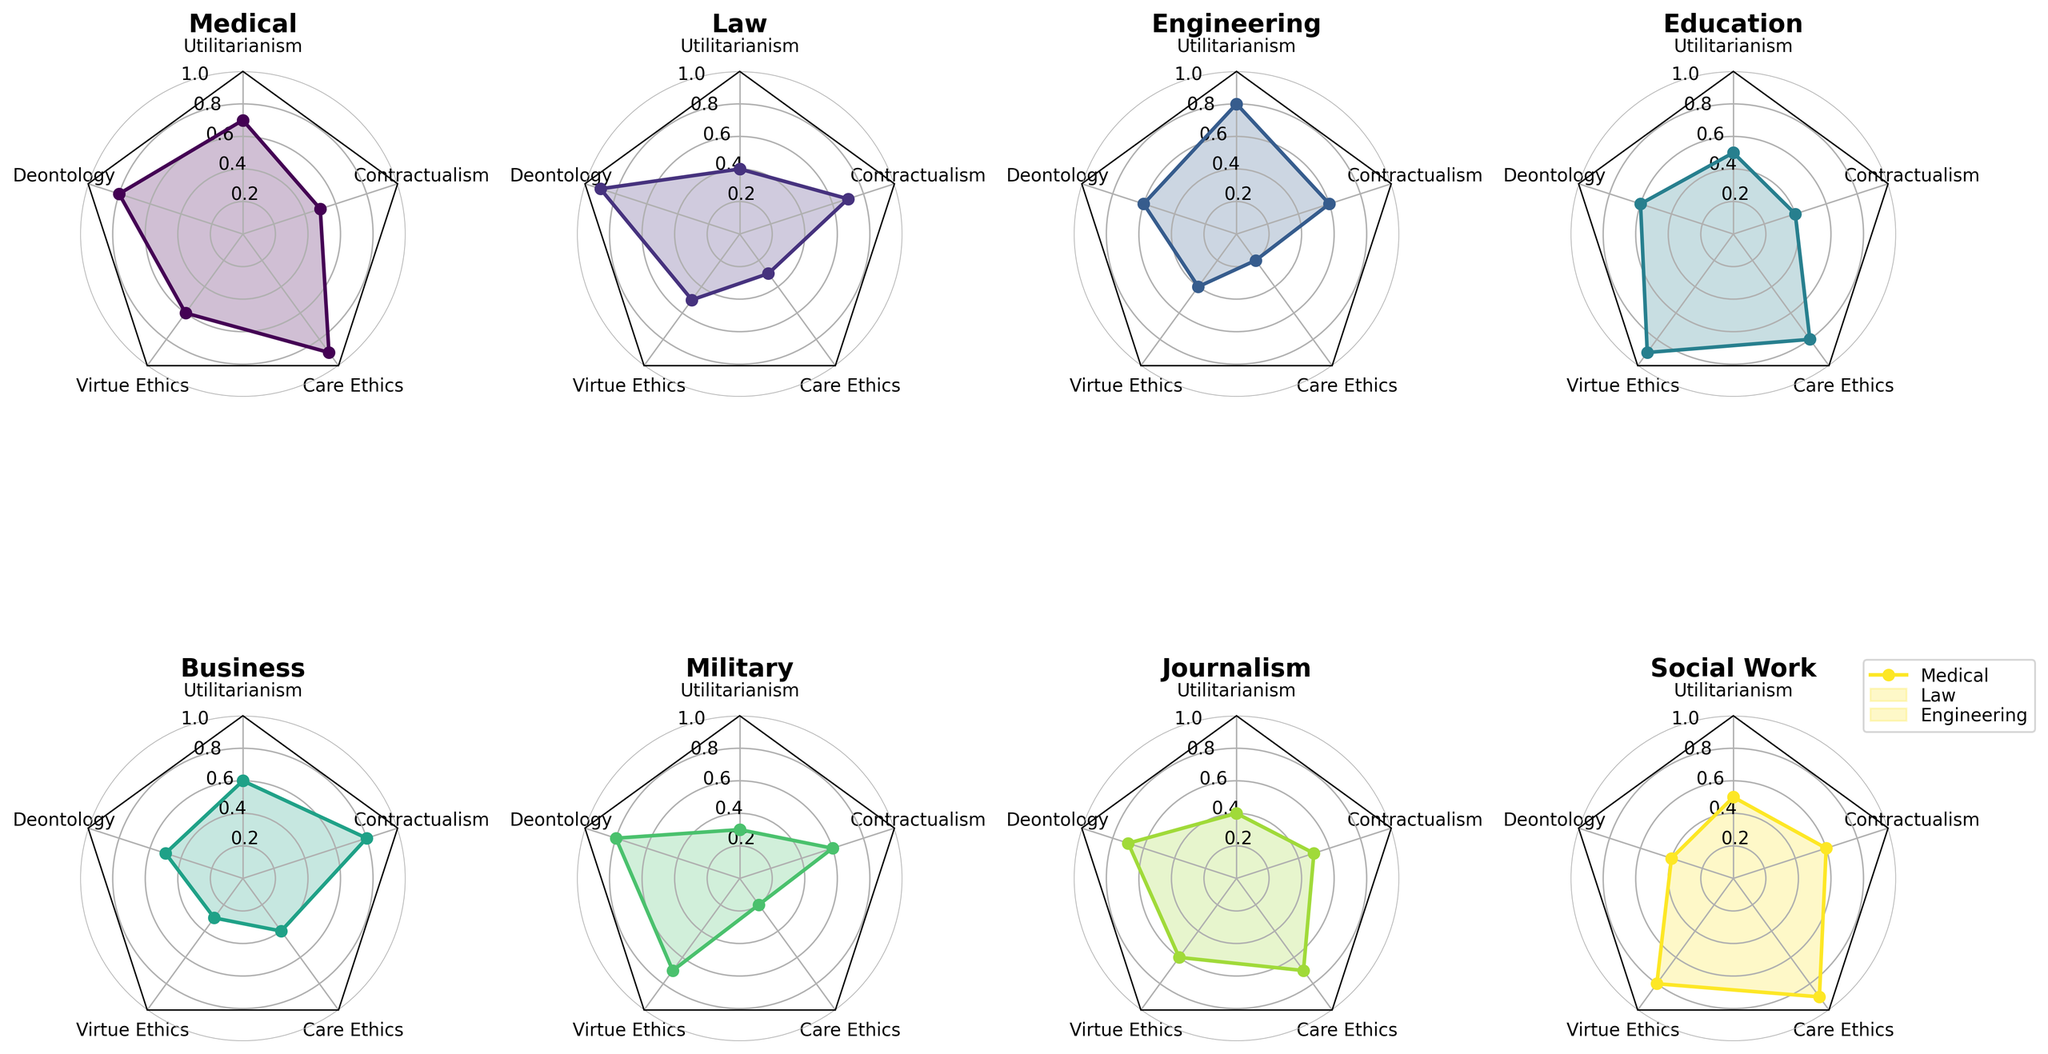What profession has the highest score in Care Ethics? By examining the radar plots, one can see that the Medical profession's radar chart has the most extended spike in the direction of Care Ethics. This indicates the highest score.
Answer: Medical Which profession has the lowest score in Utilitarianism? By looking around the radar chart at the axis labeled "Utilitarianism," we see that the Military profession has the shortest segment, indicating the lowest score.
Answer: Military Compare the scores of Medical and Law in Deontology. Which is higher? The Deontology axis on the radar chart shows that the Medical profession has a score of 0.8, while the Law profession has a score of 0.9. Therefore, Law has a higher score.
Answer: Law What is the average score of Engineering in all ethical frameworks? The scores for Engineering are: Utilitarianism (0.8), Deontology (0.6), Virtue Ethics (0.4), Care Ethics (0.2), and Contractualism (0.6). Adding these gives 2.6, divided by 5 (the number of frameworks) results in an average of 2.6 / 5 = 0.52.
Answer: 0.52 What profession has the most balanced scores across all ethical frameworks? By visually inspecting the radar charts, Education shows relatively even lengths for all five frameworks, suggesting balance.
Answer: Education Compare the variance in scores for Social Work and Business. Which one is less variable? Social Work's scores are 0.5, 0.4, 0.8, 0.9, and 0.6. Business's scores are 0.6, 0.5, 0.3, 0.4, and 0.8. Social Work has less variation between its highest and lowest scores (0.9 - 0.4 = 0.5) compared to Business (0.8 - 0.3 = 0.5).
Answer: Social Work For Journalism, rank the scores in ascending order. Journalism's scores are: Utilitarianism (0.4), Deontology (0.7), Virtue Ethics (0.6), Care Ethics (0.7), and Contractualism (0.5). Sorting these gives 0.4, 0.5, 0.6, 0.7, 0.7.
Answer: 0.4, 0.5, 0.6, 0.7, 0.7 Which two professions have the same score in Virtue Ethics? By checking the axis for Virtue Ethics in all radar charts, both Medical and Journalism have scores of 0.6.
Answer: Medical, Journalism What is the difference between the highest and lowest scores in Education? Education's scores are: Utilitarianism (0.5), Deontology (0.6), Virtue Ethics (0.9), Care Ethics (0.8), and Contractualism (0.4). The highest is 0.9 and the lowest is 0.4, so the difference is 0.9 - 0.4 = 0.5.
Answer: 0.5 